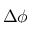Convert formula to latex. <formula><loc_0><loc_0><loc_500><loc_500>\Delta \phi</formula> 